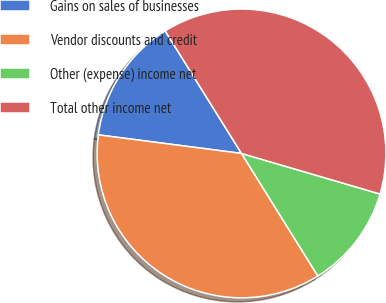<chart> <loc_0><loc_0><loc_500><loc_500><pie_chart><fcel>Gains on sales of businesses<fcel>Vendor discounts and credit<fcel>Other (expense) income net<fcel>Total other income net<nl><fcel>14.08%<fcel>35.92%<fcel>11.6%<fcel>38.4%<nl></chart> 